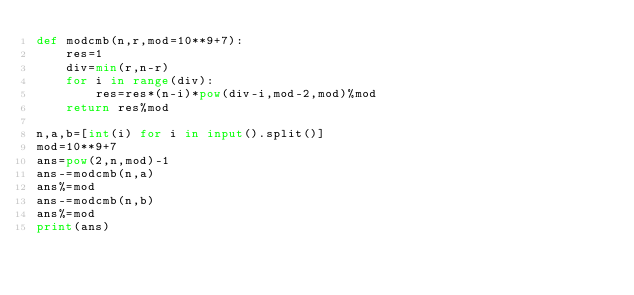Convert code to text. <code><loc_0><loc_0><loc_500><loc_500><_Python_>def modcmb(n,r,mod=10**9+7):
    res=1
    div=min(r,n-r)
    for i in range(div):
        res=res*(n-i)*pow(div-i,mod-2,mod)%mod
    return res%mod

n,a,b=[int(i) for i in input().split()]
mod=10**9+7
ans=pow(2,n,mod)-1
ans-=modcmb(n,a)
ans%=mod
ans-=modcmb(n,b)
ans%=mod
print(ans)</code> 